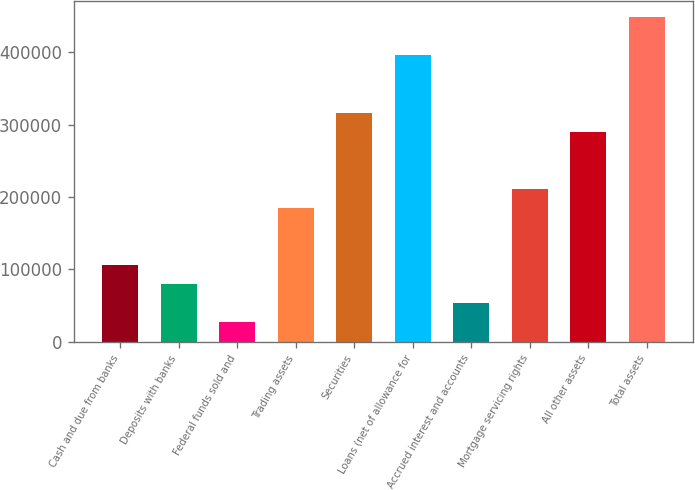Convert chart to OTSL. <chart><loc_0><loc_0><loc_500><loc_500><bar_chart><fcel>Cash and due from banks<fcel>Deposits with banks<fcel>Federal funds sold and<fcel>Trading assets<fcel>Securities<fcel>Loans (net of allowance for<fcel>Accrued interest and accounts<fcel>Mortgage servicing rights<fcel>All other assets<fcel>Total assets<nl><fcel>105947<fcel>79606.8<fcel>26925.6<fcel>184969<fcel>316672<fcel>395694<fcel>53266.2<fcel>211310<fcel>290332<fcel>448375<nl></chart> 